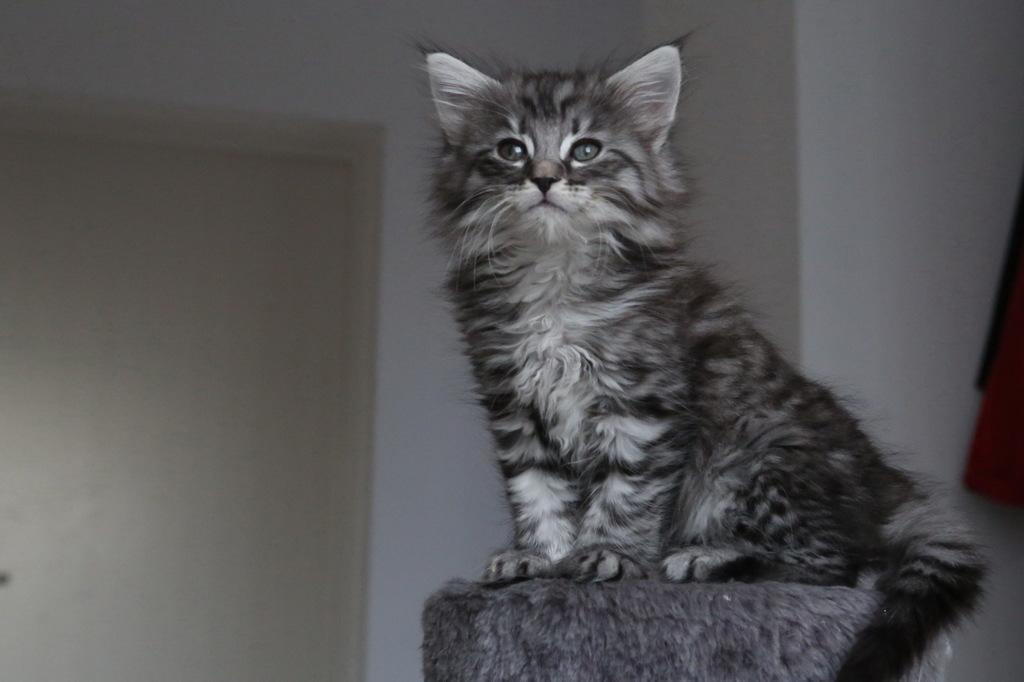What animal can be seen in the image? There is a cat in the image. What is the cat doing in the image? The cat is sitting on an object. What architectural feature is visible in the image? There is a door visible in the image. What is behind the cat in the image? There is a wall behind the cat. What can be seen on the right side of the image? There are objects on the right side of the image. What type of treatment is the cat receiving in the image? There is no indication in the image that the cat is receiving any treatment. 